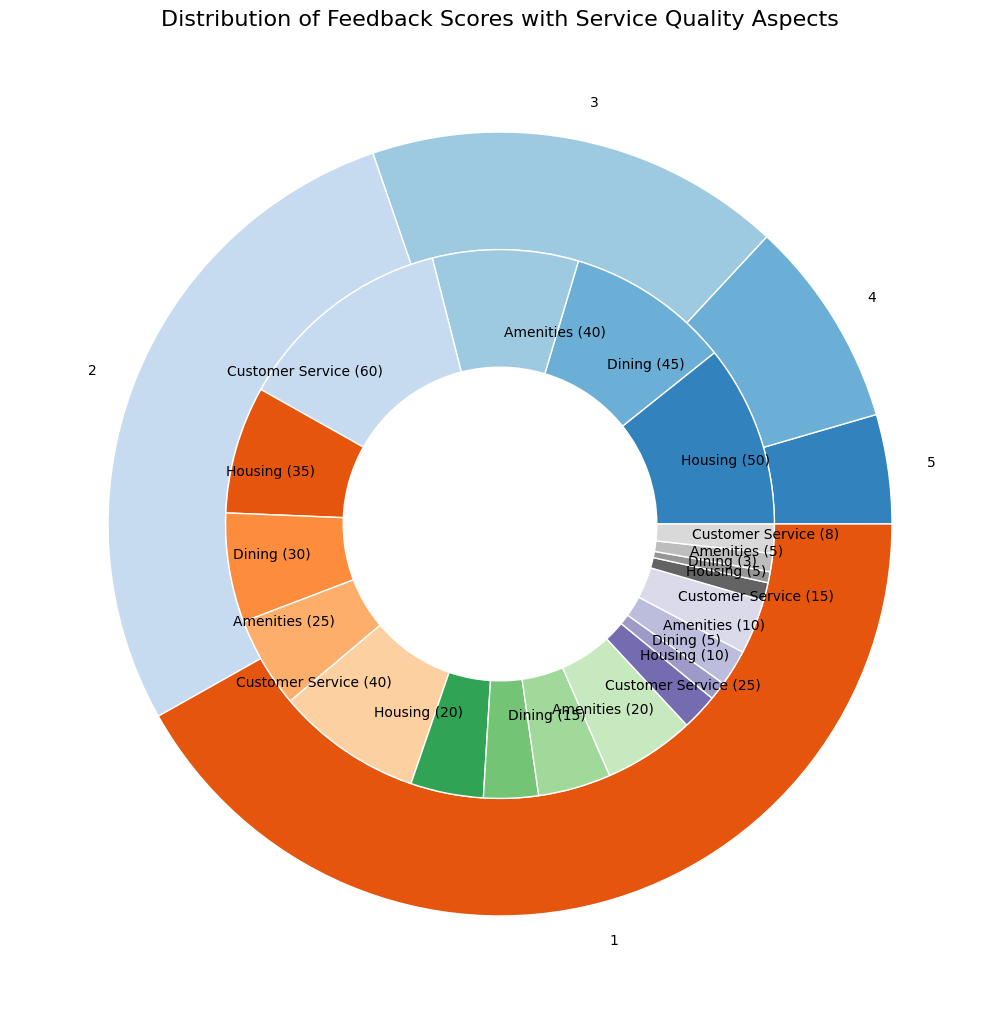What’s the total number of comments for the feedback score of 4? To find the total number of comments for the feedback score of 4, sum the comments for each service quality aspect in that score: Housing (35) + Dining (30) + Amenities (25) + Customer Service (40) which equals 130.
Answer: 130 Which service quality aspect received the highest number of comments for the feedback score of 5? To find this, look at the comments count within the feedback score of 5. Customer Service has the highest number of comments, which is 60.
Answer: Customer Service In the feedback score of 1, which service quality aspect received fewer comments, Amenities or Housing? In the feedback score of 1, Amenities received 5 comments whereas Housing received 5 comments as well. They are equal.
Answer: They are equal Compare the total comments for Dining across all feedback scores to the total comments for Housing. Which has more, and by how much? Sum the comments for Dining (45 + 30 + 15 + 5 + 3 = 98) and Housing (50 + 35 + 20 + 10 + 5 = 120). Compare the two sums: 120 - 98 = 22. Housing has more comments by 22.
Answer: Housing by 22 What proportion of the total comments for feedback score 3 does the Customer Service category represent? First, find the total number of comments for feedback score 3 by summing its categories (20 + 15 + 20 + 25 = 80). Then, find the proportion for Customer Service: 25/80 = 0.3125 or 31.25%.
Answer: 31.25% Is the number of comments for Amenities in feedback score 4 greater than or less than the number of comments for Dining in feedback score 5? Amenities in feedback score 4 has 25 comments, and Dining in feedback score 5 has 45 comments. Since 25 is less than 45, we can conclude that it is less.
Answer: Less Which feedback score has the highest total number of comments, and what is that number? Add up the comments for each feedback score and compare them: 
5 (195), 4 (130), 3 (80), 2 (40), 1 (21). Feedback score 5 has the highest total number of comments, which is 195.
Answer: 5, 195 What is the combined total number of comments for Customer Service across all feedback scores? Sum the comments for Customer Service across all feedback scores (60 + 40 + 25 + 15 + 8). This gives 148.
Answer: 148 